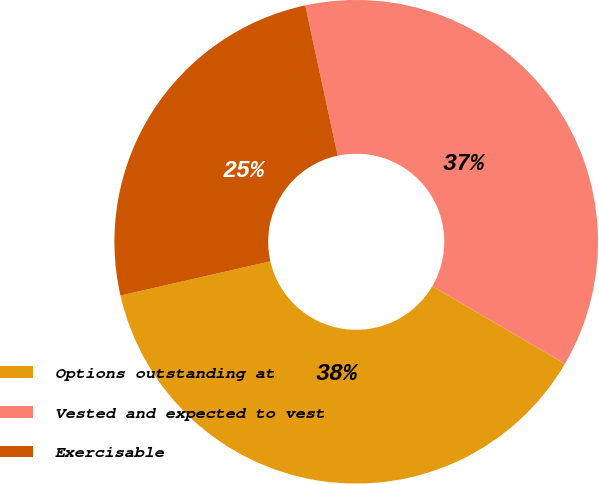<chart> <loc_0><loc_0><loc_500><loc_500><pie_chart><fcel>Options outstanding at<fcel>Vested and expected to vest<fcel>Exercisable<nl><fcel>38.01%<fcel>36.8%<fcel>25.19%<nl></chart> 